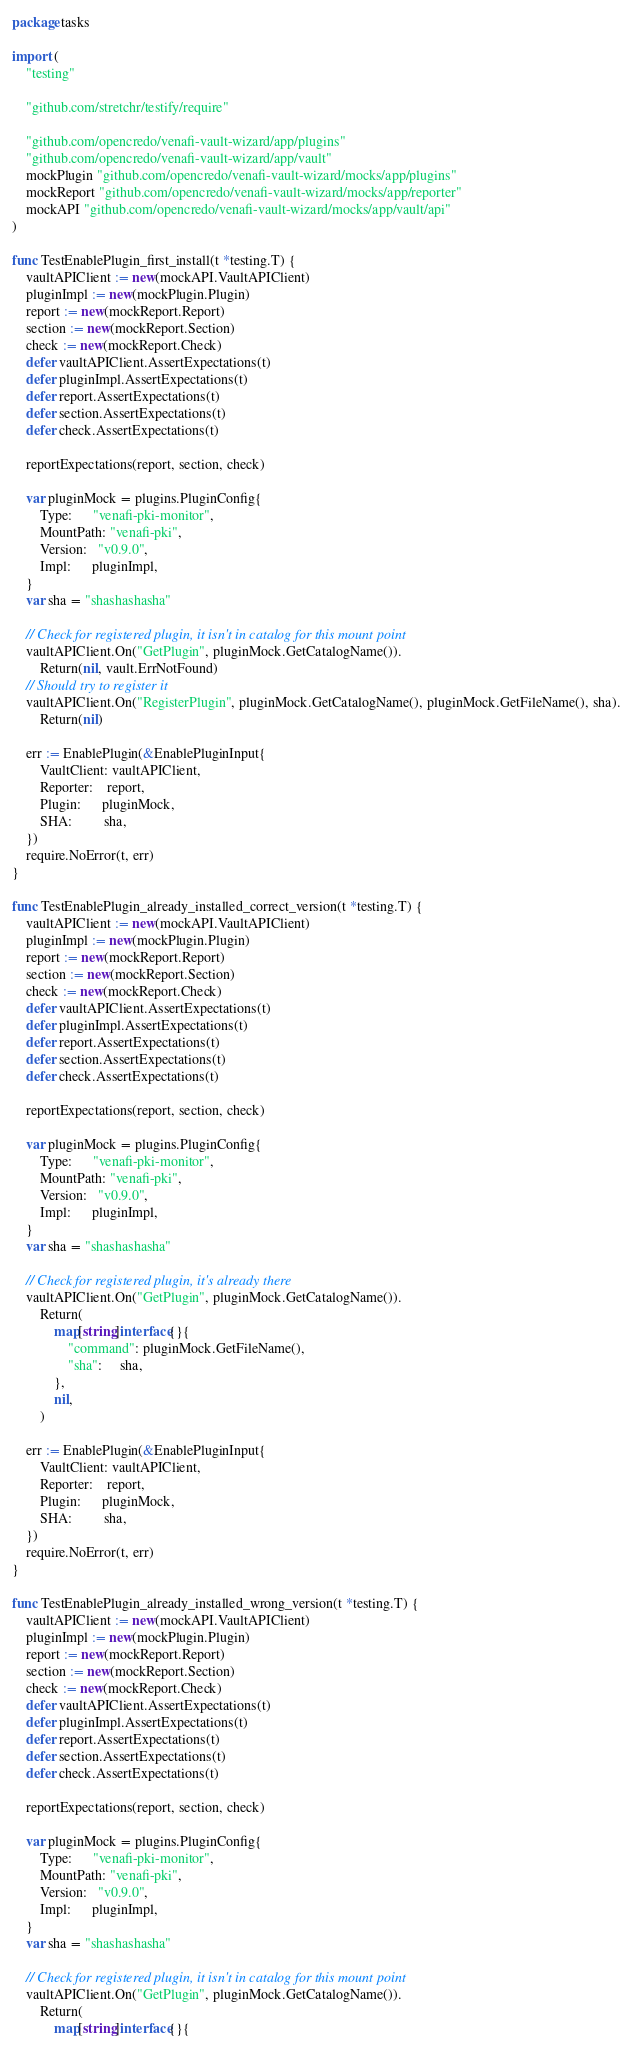<code> <loc_0><loc_0><loc_500><loc_500><_Go_>package tasks

import (
	"testing"

	"github.com/stretchr/testify/require"

	"github.com/opencredo/venafi-vault-wizard/app/plugins"
	"github.com/opencredo/venafi-vault-wizard/app/vault"
	mockPlugin "github.com/opencredo/venafi-vault-wizard/mocks/app/plugins"
	mockReport "github.com/opencredo/venafi-vault-wizard/mocks/app/reporter"
	mockAPI "github.com/opencredo/venafi-vault-wizard/mocks/app/vault/api"
)

func TestEnablePlugin_first_install(t *testing.T) {
	vaultAPIClient := new(mockAPI.VaultAPIClient)
	pluginImpl := new(mockPlugin.Plugin)
	report := new(mockReport.Report)
	section := new(mockReport.Section)
	check := new(mockReport.Check)
	defer vaultAPIClient.AssertExpectations(t)
	defer pluginImpl.AssertExpectations(t)
	defer report.AssertExpectations(t)
	defer section.AssertExpectations(t)
	defer check.AssertExpectations(t)

	reportExpectations(report, section, check)

	var pluginMock = plugins.PluginConfig{
		Type:      "venafi-pki-monitor",
		MountPath: "venafi-pki",
		Version:   "v0.9.0",
		Impl:      pluginImpl,
	}
	var sha = "shashashasha"

	// Check for registered plugin, it isn't in catalog for this mount point
	vaultAPIClient.On("GetPlugin", pluginMock.GetCatalogName()).
		Return(nil, vault.ErrNotFound)
	// Should try to register it
	vaultAPIClient.On("RegisterPlugin", pluginMock.GetCatalogName(), pluginMock.GetFileName(), sha).
		Return(nil)

	err := EnablePlugin(&EnablePluginInput{
		VaultClient: vaultAPIClient,
		Reporter:    report,
		Plugin:      pluginMock,
		SHA:         sha,
	})
	require.NoError(t, err)
}

func TestEnablePlugin_already_installed_correct_version(t *testing.T) {
	vaultAPIClient := new(mockAPI.VaultAPIClient)
	pluginImpl := new(mockPlugin.Plugin)
	report := new(mockReport.Report)
	section := new(mockReport.Section)
	check := new(mockReport.Check)
	defer vaultAPIClient.AssertExpectations(t)
	defer pluginImpl.AssertExpectations(t)
	defer report.AssertExpectations(t)
	defer section.AssertExpectations(t)
	defer check.AssertExpectations(t)

	reportExpectations(report, section, check)

	var pluginMock = plugins.PluginConfig{
		Type:      "venafi-pki-monitor",
		MountPath: "venafi-pki",
		Version:   "v0.9.0",
		Impl:      pluginImpl,
	}
	var sha = "shashashasha"

	// Check for registered plugin, it's already there
	vaultAPIClient.On("GetPlugin", pluginMock.GetCatalogName()).
		Return(
			map[string]interface{}{
				"command": pluginMock.GetFileName(),
				"sha":     sha,
			},
			nil,
		)

	err := EnablePlugin(&EnablePluginInput{
		VaultClient: vaultAPIClient,
		Reporter:    report,
		Plugin:      pluginMock,
		SHA:         sha,
	})
	require.NoError(t, err)
}

func TestEnablePlugin_already_installed_wrong_version(t *testing.T) {
	vaultAPIClient := new(mockAPI.VaultAPIClient)
	pluginImpl := new(mockPlugin.Plugin)
	report := new(mockReport.Report)
	section := new(mockReport.Section)
	check := new(mockReport.Check)
	defer vaultAPIClient.AssertExpectations(t)
	defer pluginImpl.AssertExpectations(t)
	defer report.AssertExpectations(t)
	defer section.AssertExpectations(t)
	defer check.AssertExpectations(t)

	reportExpectations(report, section, check)

	var pluginMock = plugins.PluginConfig{
		Type:      "venafi-pki-monitor",
		MountPath: "venafi-pki",
		Version:   "v0.9.0",
		Impl:      pluginImpl,
	}
	var sha = "shashashasha"

	// Check for registered plugin, it isn't in catalog for this mount point
	vaultAPIClient.On("GetPlugin", pluginMock.GetCatalogName()).
		Return(
			map[string]interface{}{</code> 